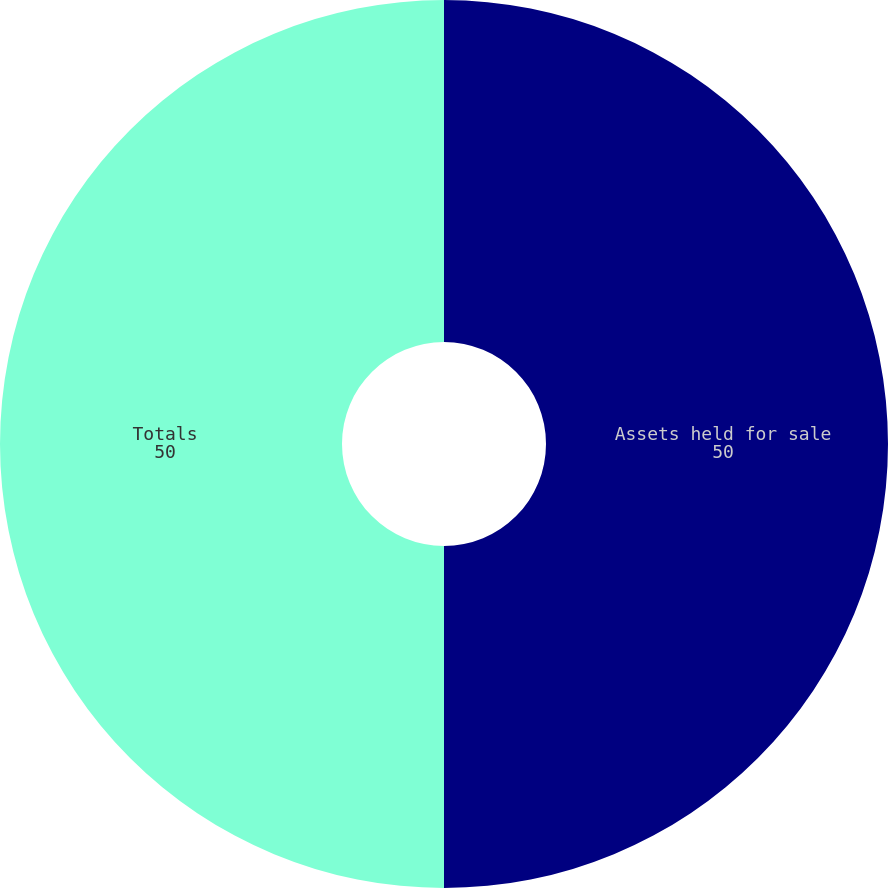Convert chart. <chart><loc_0><loc_0><loc_500><loc_500><pie_chart><fcel>Assets held for sale<fcel>Totals<nl><fcel>50.0%<fcel>50.0%<nl></chart> 